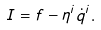<formula> <loc_0><loc_0><loc_500><loc_500>I = f - \eta ^ { i } \dot { q } ^ { i } .</formula> 